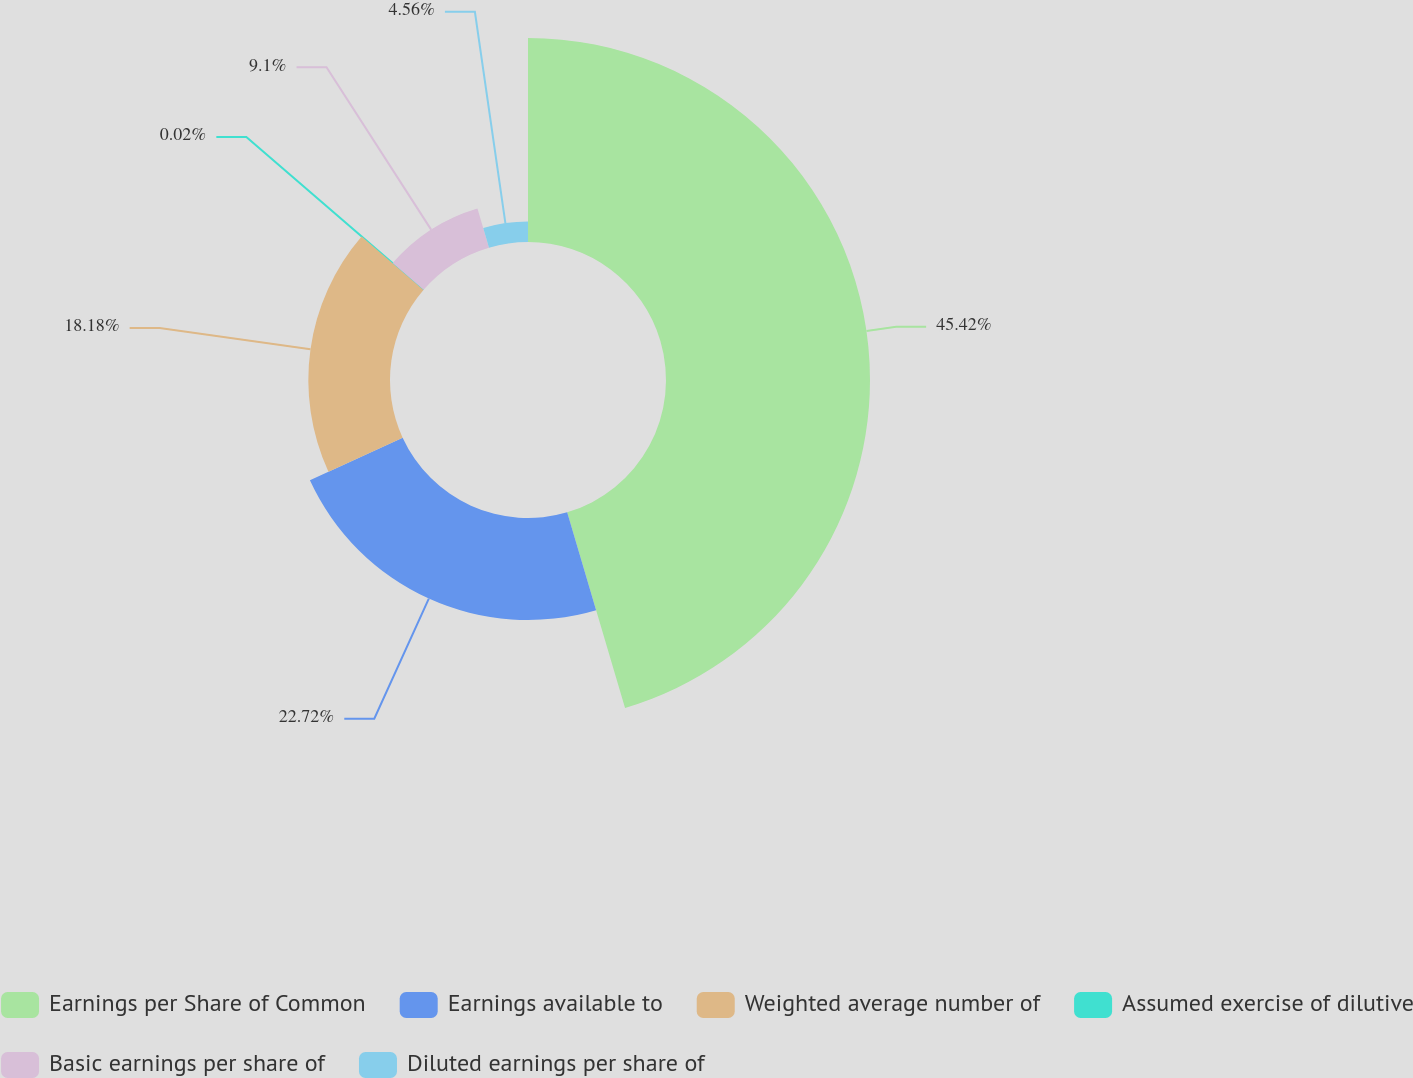Convert chart to OTSL. <chart><loc_0><loc_0><loc_500><loc_500><pie_chart><fcel>Earnings per Share of Common<fcel>Earnings available to<fcel>Weighted average number of<fcel>Assumed exercise of dilutive<fcel>Basic earnings per share of<fcel>Diluted earnings per share of<nl><fcel>45.42%<fcel>22.72%<fcel>18.18%<fcel>0.02%<fcel>9.1%<fcel>4.56%<nl></chart> 